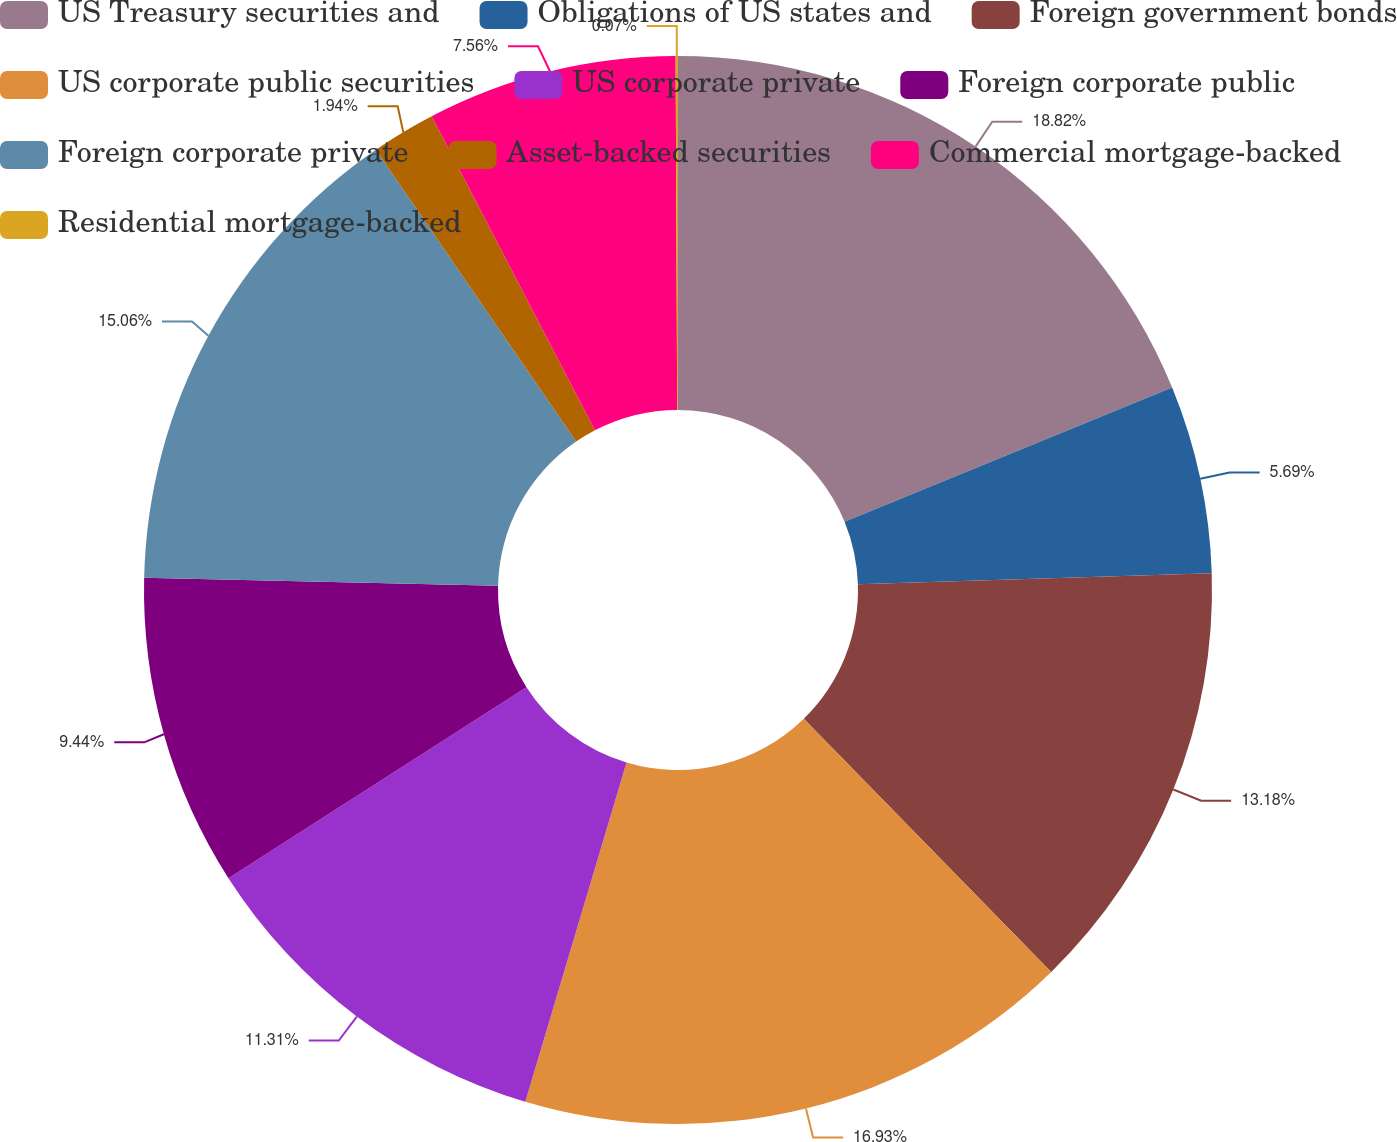Convert chart. <chart><loc_0><loc_0><loc_500><loc_500><pie_chart><fcel>US Treasury securities and<fcel>Obligations of US states and<fcel>Foreign government bonds<fcel>US corporate public securities<fcel>US corporate private<fcel>Foreign corporate public<fcel>Foreign corporate private<fcel>Asset-backed securities<fcel>Commercial mortgage-backed<fcel>Residential mortgage-backed<nl><fcel>18.81%<fcel>5.69%<fcel>13.18%<fcel>16.93%<fcel>11.31%<fcel>9.44%<fcel>15.06%<fcel>1.94%<fcel>7.56%<fcel>0.07%<nl></chart> 